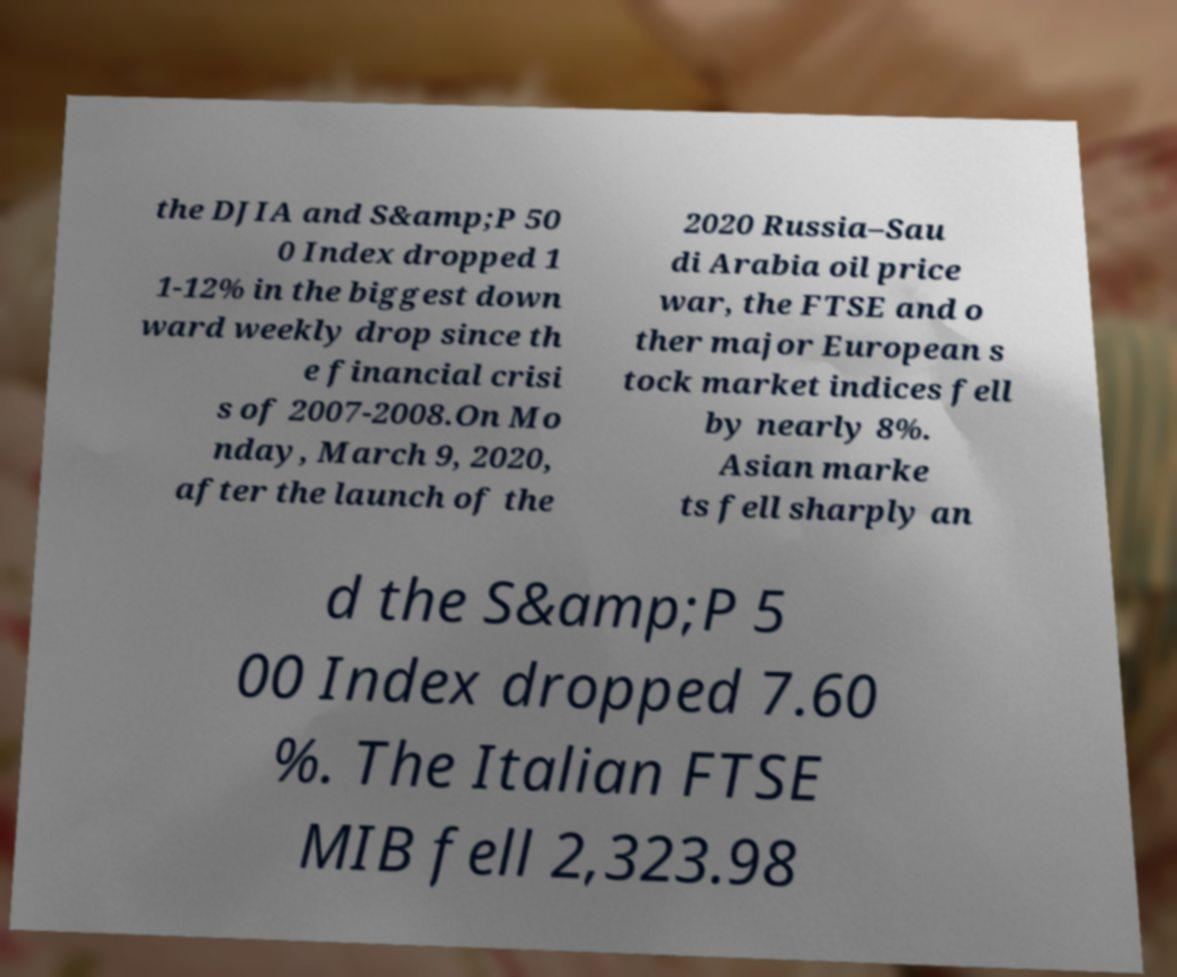Can you read and provide the text displayed in the image?This photo seems to have some interesting text. Can you extract and type it out for me? the DJIA and S&amp;P 50 0 Index dropped 1 1-12% in the biggest down ward weekly drop since th e financial crisi s of 2007-2008.On Mo nday, March 9, 2020, after the launch of the 2020 Russia–Sau di Arabia oil price war, the FTSE and o ther major European s tock market indices fell by nearly 8%. Asian marke ts fell sharply an d the S&amp;P 5 00 Index dropped 7.60 %. The Italian FTSE MIB fell 2,323.98 